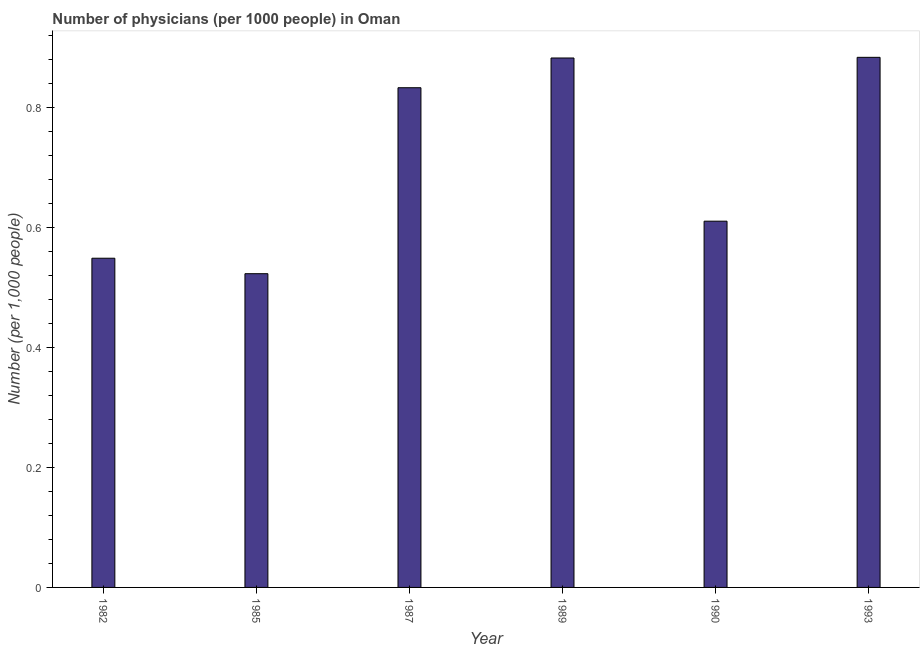Does the graph contain grids?
Your answer should be compact. No. What is the title of the graph?
Make the answer very short. Number of physicians (per 1000 people) in Oman. What is the label or title of the X-axis?
Ensure brevity in your answer.  Year. What is the label or title of the Y-axis?
Keep it short and to the point. Number (per 1,0 people). What is the number of physicians in 1993?
Your answer should be very brief. 0.88. Across all years, what is the maximum number of physicians?
Make the answer very short. 0.88. Across all years, what is the minimum number of physicians?
Provide a succinct answer. 0.52. In which year was the number of physicians maximum?
Offer a very short reply. 1993. In which year was the number of physicians minimum?
Make the answer very short. 1985. What is the sum of the number of physicians?
Provide a short and direct response. 4.28. What is the difference between the number of physicians in 1990 and 1993?
Provide a short and direct response. -0.27. What is the average number of physicians per year?
Ensure brevity in your answer.  0.71. What is the median number of physicians?
Your answer should be very brief. 0.72. Do a majority of the years between 1982 and 1989 (inclusive) have number of physicians greater than 0.04 ?
Make the answer very short. Yes. What is the ratio of the number of physicians in 1982 to that in 1990?
Offer a very short reply. 0.9. Is the difference between the number of physicians in 1985 and 1993 greater than the difference between any two years?
Offer a very short reply. Yes. What is the difference between the highest and the second highest number of physicians?
Offer a terse response. 0. Is the sum of the number of physicians in 1989 and 1990 greater than the maximum number of physicians across all years?
Offer a terse response. Yes. What is the difference between the highest and the lowest number of physicians?
Your answer should be very brief. 0.36. Are all the bars in the graph horizontal?
Provide a succinct answer. No. How many years are there in the graph?
Give a very brief answer. 6. What is the difference between two consecutive major ticks on the Y-axis?
Offer a terse response. 0.2. What is the Number (per 1,000 people) of 1982?
Provide a succinct answer. 0.55. What is the Number (per 1,000 people) in 1985?
Provide a short and direct response. 0.52. What is the Number (per 1,000 people) in 1987?
Provide a short and direct response. 0.83. What is the Number (per 1,000 people) of 1989?
Ensure brevity in your answer.  0.88. What is the Number (per 1,000 people) in 1990?
Provide a succinct answer. 0.61. What is the Number (per 1,000 people) in 1993?
Ensure brevity in your answer.  0.88. What is the difference between the Number (per 1,000 people) in 1982 and 1985?
Your response must be concise. 0.03. What is the difference between the Number (per 1,000 people) in 1982 and 1987?
Provide a short and direct response. -0.28. What is the difference between the Number (per 1,000 people) in 1982 and 1989?
Your response must be concise. -0.33. What is the difference between the Number (per 1,000 people) in 1982 and 1990?
Your response must be concise. -0.06. What is the difference between the Number (per 1,000 people) in 1982 and 1993?
Your answer should be compact. -0.34. What is the difference between the Number (per 1,000 people) in 1985 and 1987?
Keep it short and to the point. -0.31. What is the difference between the Number (per 1,000 people) in 1985 and 1989?
Provide a succinct answer. -0.36. What is the difference between the Number (per 1,000 people) in 1985 and 1990?
Your answer should be compact. -0.09. What is the difference between the Number (per 1,000 people) in 1985 and 1993?
Offer a very short reply. -0.36. What is the difference between the Number (per 1,000 people) in 1987 and 1989?
Give a very brief answer. -0.05. What is the difference between the Number (per 1,000 people) in 1987 and 1990?
Ensure brevity in your answer.  0.22. What is the difference between the Number (per 1,000 people) in 1987 and 1993?
Provide a succinct answer. -0.05. What is the difference between the Number (per 1,000 people) in 1989 and 1990?
Your response must be concise. 0.27. What is the difference between the Number (per 1,000 people) in 1989 and 1993?
Your answer should be compact. -0. What is the difference between the Number (per 1,000 people) in 1990 and 1993?
Give a very brief answer. -0.27. What is the ratio of the Number (per 1,000 people) in 1982 to that in 1985?
Make the answer very short. 1.05. What is the ratio of the Number (per 1,000 people) in 1982 to that in 1987?
Give a very brief answer. 0.66. What is the ratio of the Number (per 1,000 people) in 1982 to that in 1989?
Give a very brief answer. 0.62. What is the ratio of the Number (per 1,000 people) in 1982 to that in 1990?
Provide a short and direct response. 0.9. What is the ratio of the Number (per 1,000 people) in 1982 to that in 1993?
Offer a very short reply. 0.62. What is the ratio of the Number (per 1,000 people) in 1985 to that in 1987?
Give a very brief answer. 0.63. What is the ratio of the Number (per 1,000 people) in 1985 to that in 1989?
Keep it short and to the point. 0.59. What is the ratio of the Number (per 1,000 people) in 1985 to that in 1990?
Make the answer very short. 0.86. What is the ratio of the Number (per 1,000 people) in 1985 to that in 1993?
Provide a short and direct response. 0.59. What is the ratio of the Number (per 1,000 people) in 1987 to that in 1989?
Your response must be concise. 0.94. What is the ratio of the Number (per 1,000 people) in 1987 to that in 1990?
Provide a short and direct response. 1.36. What is the ratio of the Number (per 1,000 people) in 1987 to that in 1993?
Offer a very short reply. 0.94. What is the ratio of the Number (per 1,000 people) in 1989 to that in 1990?
Your answer should be very brief. 1.45. What is the ratio of the Number (per 1,000 people) in 1990 to that in 1993?
Your answer should be very brief. 0.69. 